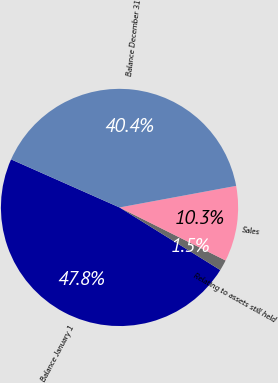Convert chart. <chart><loc_0><loc_0><loc_500><loc_500><pie_chart><fcel>Balance January 1<fcel>Relating to assets still held<fcel>Sales<fcel>Balance December 31<nl><fcel>47.79%<fcel>1.47%<fcel>10.29%<fcel>40.44%<nl></chart> 